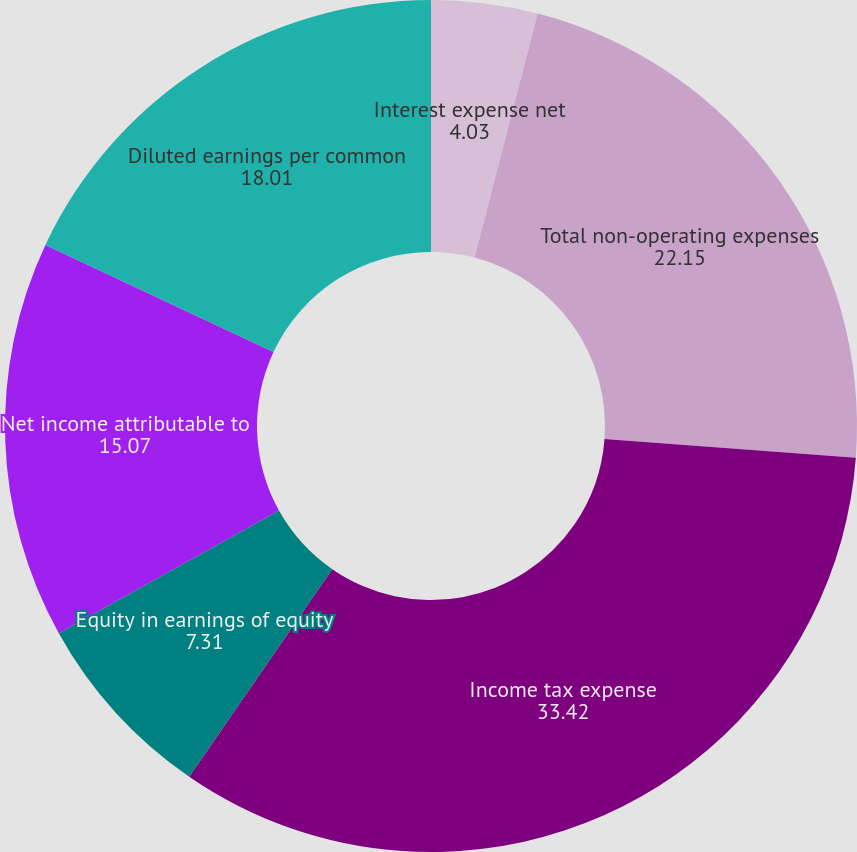Convert chart. <chart><loc_0><loc_0><loc_500><loc_500><pie_chart><fcel>Interest expense net<fcel>Total non-operating expenses<fcel>Income tax expense<fcel>Equity in earnings of equity<fcel>Net income attributable to<fcel>Diluted earnings per common<nl><fcel>4.03%<fcel>22.15%<fcel>33.42%<fcel>7.31%<fcel>15.07%<fcel>18.01%<nl></chart> 